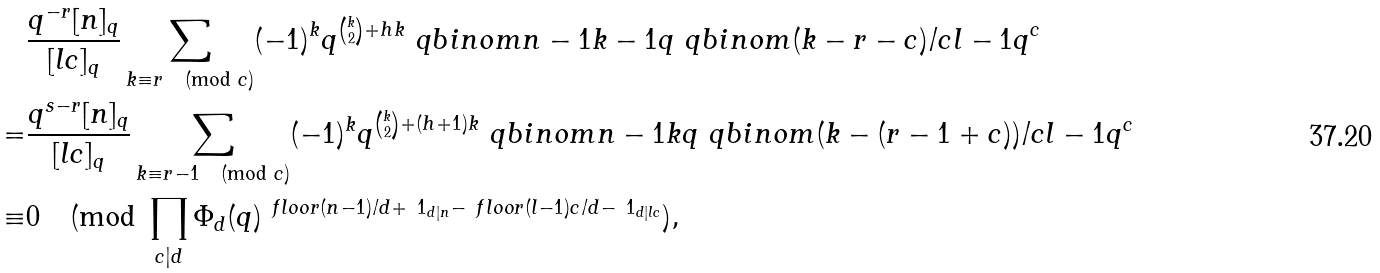<formula> <loc_0><loc_0><loc_500><loc_500>& \frac { q ^ { - r } [ n ] _ { q } } { [ l c ] _ { q } } \sum _ { k \equiv r \pmod { c } } ( - 1 ) ^ { k } q ^ { \binom { k } { 2 } + h k } \ q b i n o m { n - 1 } { k - 1 } { q } \ q b i n o m { ( k - r - c ) / c } { l - 1 } { q ^ { c } } \\ = & \frac { q ^ { s - r } [ n ] _ { q } } { [ l c ] _ { q } } \sum _ { k \equiv r - 1 \pmod { c } } ( - 1 ) ^ { k } q ^ { \binom { k } { 2 } + ( h + 1 ) k } \ q b i n o m { n - 1 } { k } { q } \ q b i n o m { ( k - ( r - 1 + c ) ) / c } { l - 1 } { q ^ { c } } \\ \equiv & 0 \pmod { \prod _ { c | d } \Phi _ { d } ( q ) ^ { \ f l o o r { ( n - 1 ) / d } + \ 1 _ { d | n } - \ f l o o r { ( l - 1 ) c / d } - \ 1 _ { d | l c } } } ,</formula> 